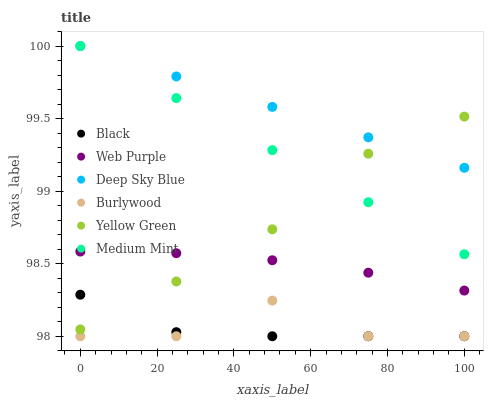Does Black have the minimum area under the curve?
Answer yes or no. Yes. Does Deep Sky Blue have the maximum area under the curve?
Answer yes or no. Yes. Does Yellow Green have the minimum area under the curve?
Answer yes or no. No. Does Yellow Green have the maximum area under the curve?
Answer yes or no. No. Is Medium Mint the smoothest?
Answer yes or no. Yes. Is Burlywood the roughest?
Answer yes or no. Yes. Is Yellow Green the smoothest?
Answer yes or no. No. Is Yellow Green the roughest?
Answer yes or no. No. Does Burlywood have the lowest value?
Answer yes or no. Yes. Does Yellow Green have the lowest value?
Answer yes or no. No. Does Deep Sky Blue have the highest value?
Answer yes or no. Yes. Does Yellow Green have the highest value?
Answer yes or no. No. Is Black less than Medium Mint?
Answer yes or no. Yes. Is Deep Sky Blue greater than Web Purple?
Answer yes or no. Yes. Does Medium Mint intersect Deep Sky Blue?
Answer yes or no. Yes. Is Medium Mint less than Deep Sky Blue?
Answer yes or no. No. Is Medium Mint greater than Deep Sky Blue?
Answer yes or no. No. Does Black intersect Medium Mint?
Answer yes or no. No. 